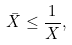Convert formula to latex. <formula><loc_0><loc_0><loc_500><loc_500>\bar { X } \leq \frac { 1 } { X } ,</formula> 